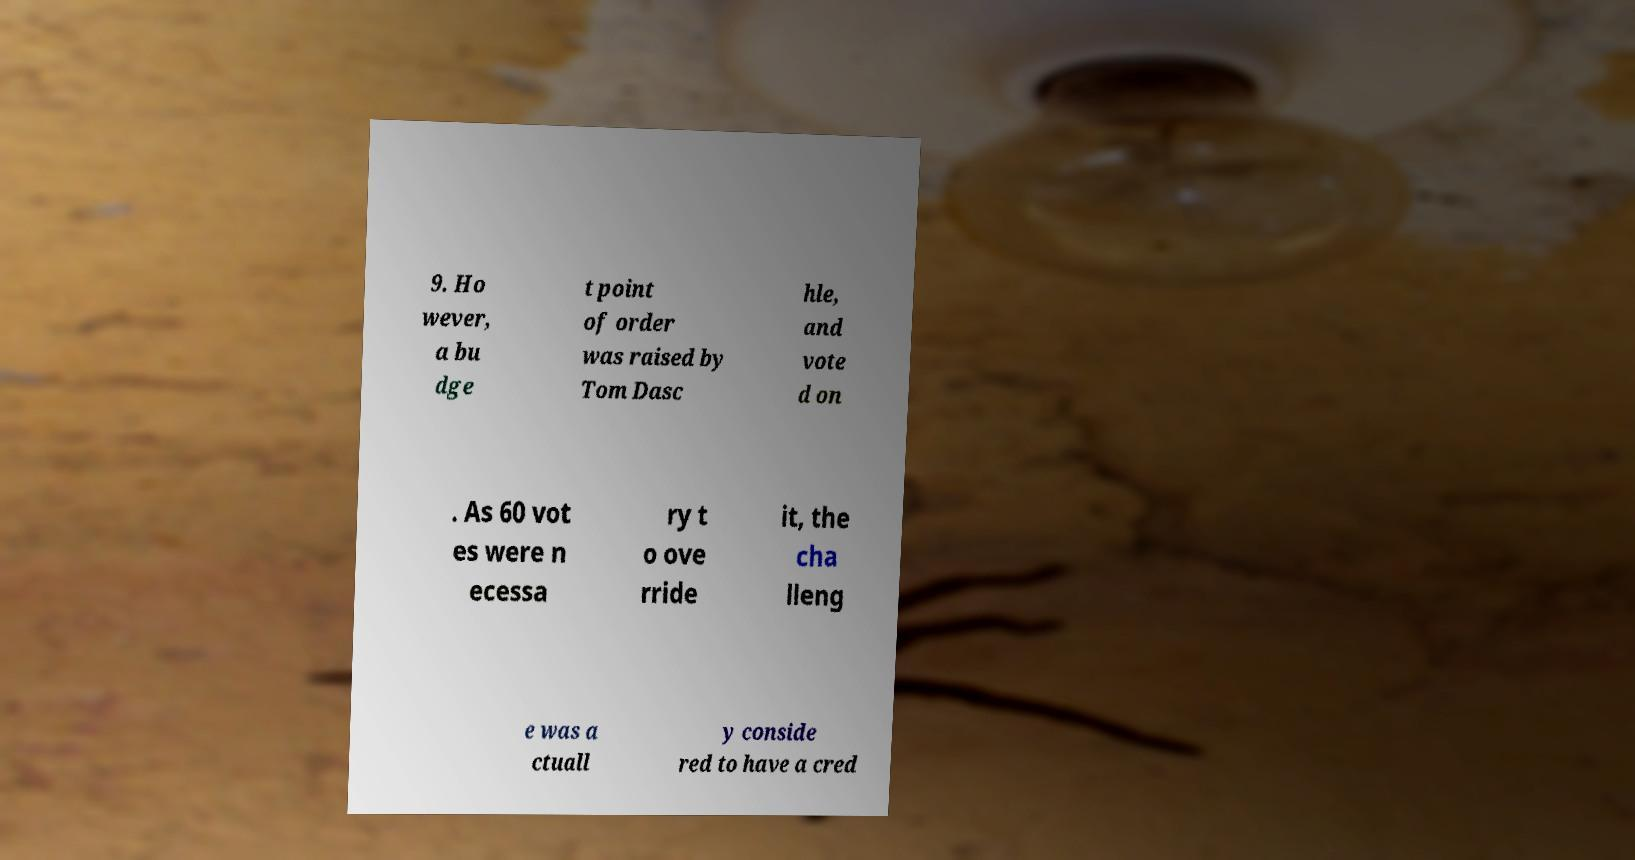What messages or text are displayed in this image? I need them in a readable, typed format. 9. Ho wever, a bu dge t point of order was raised by Tom Dasc hle, and vote d on . As 60 vot es were n ecessa ry t o ove rride it, the cha lleng e was a ctuall y conside red to have a cred 